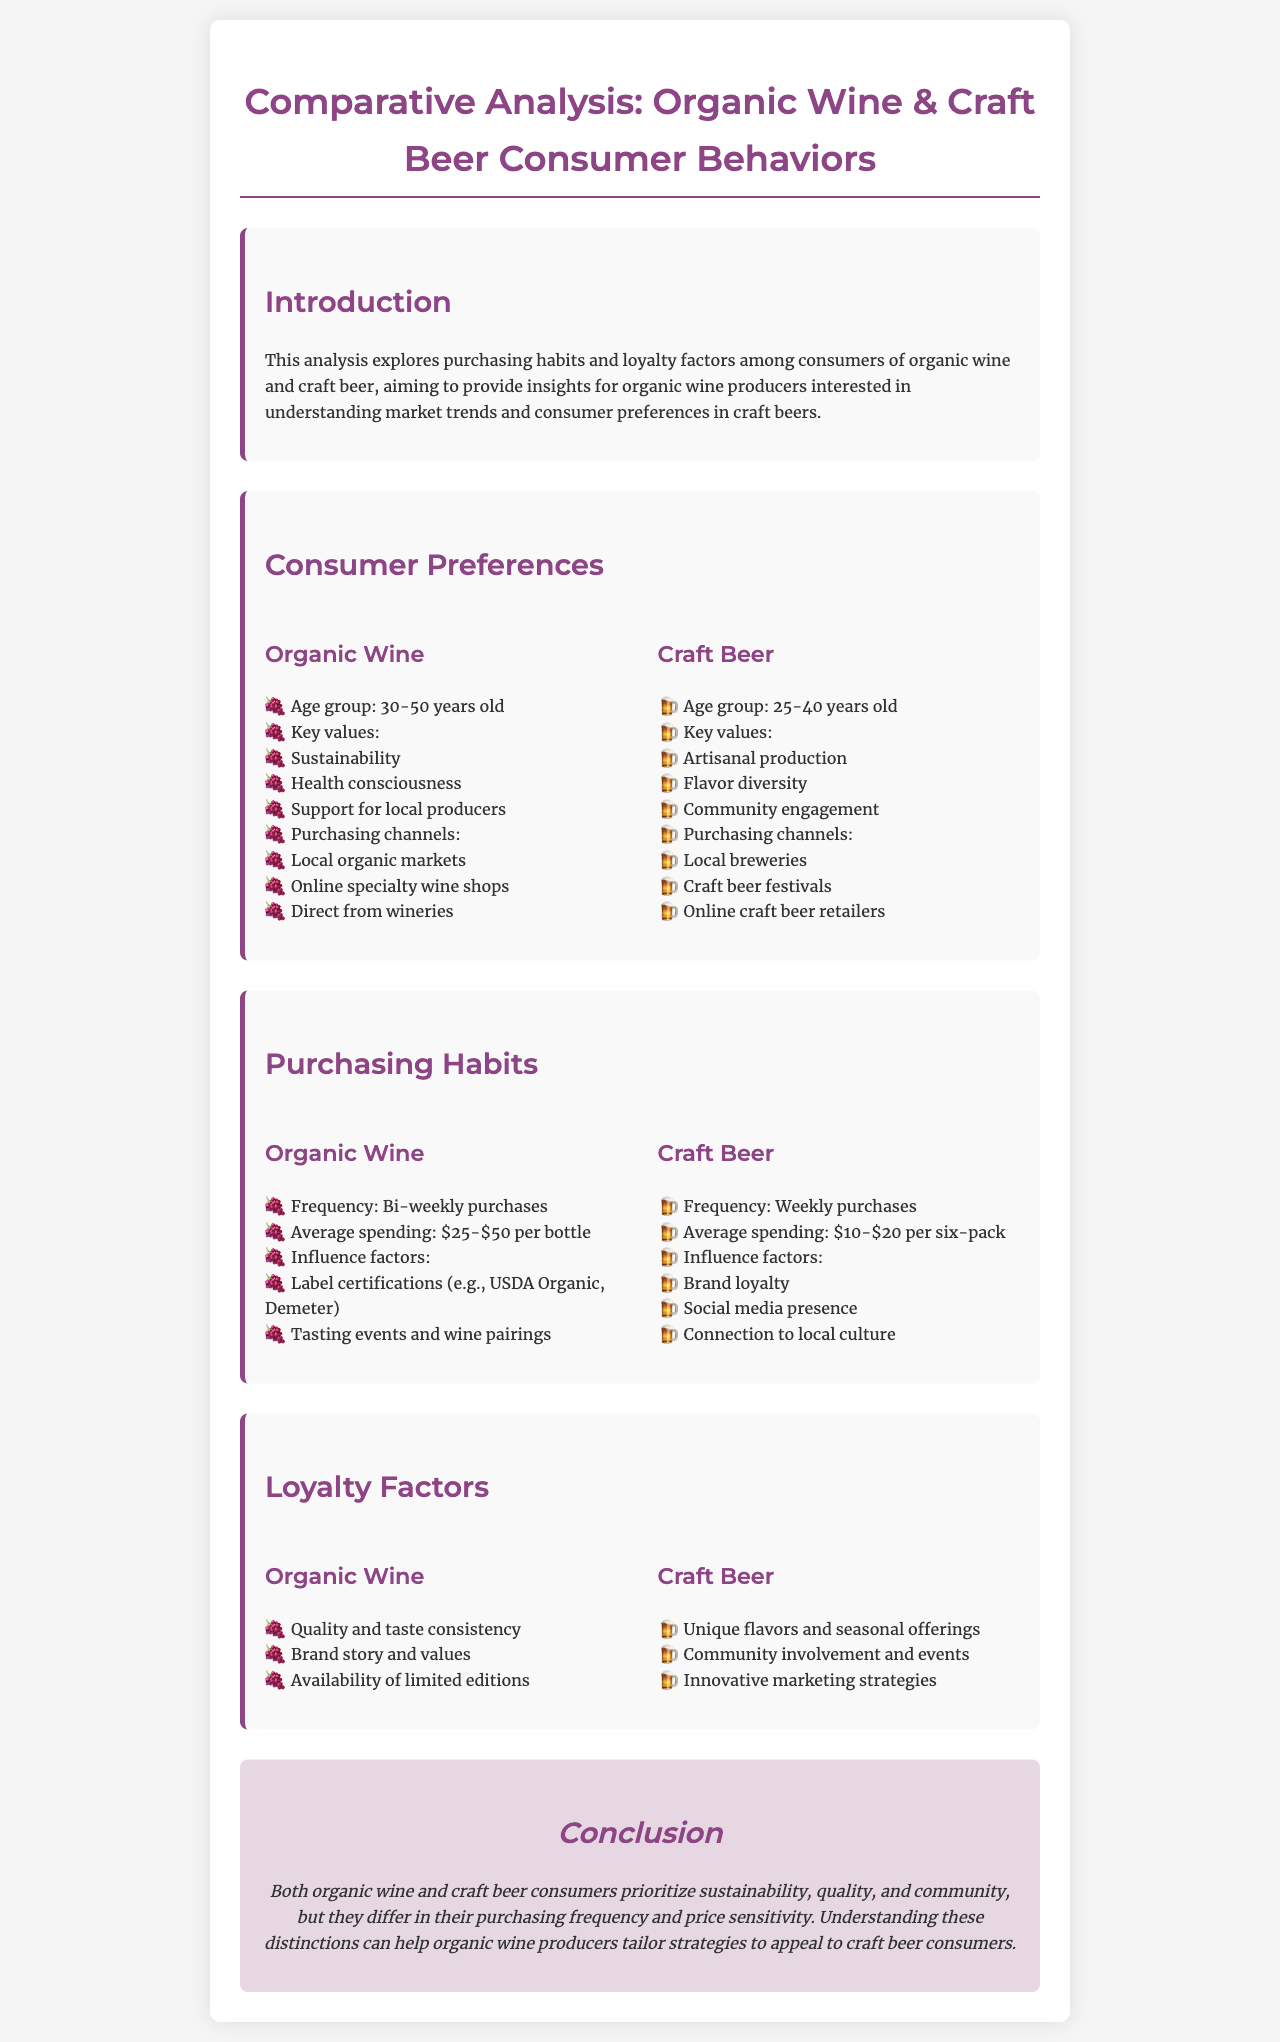What is the age group for organic wine consumers? The age group for organic wine consumers is specified as 30-50 years old in the document.
Answer: 30-50 years old What is the average spending on organic wine per bottle? The document states that the average spending on organic wine per bottle ranges from $25 to $50.
Answer: $25-$50 Which purchasing channel is least likely for craft beer consumers? The document lists purchasing channels for craft beer consumers; among these, "local organic markets" is not mentioned, implying it's least likely.
Answer: Local organic markets What is the frequency of purchasing craft beer? According to the document, the frequency of purchasing craft beer is specified as weekly.
Answer: Weekly What influences organic wine purchasing habits? The document indicates that label certifications and tasting events influence organic wine purchasing habits.
Answer: Label certifications and tasting events Which value is associated with craft beer consumers? The document mentions that 'artisanal production' is a key value for craft beer consumers.
Answer: Artisanal production What is a loyalty factor for organic wine? The document identifies 'quality and taste consistency' as a loyalty factor for organic wine consumers.
Answer: Quality and taste consistency What is a unique factor for craft beer consumers' loyalty? The document states that 'unique flavors and seasonal offerings' are a unique factor for craft beer consumers' loyalty.
Answer: Unique flavors and seasonal offerings What do both consumer groups prioritize? The document concludes that both organic wine and craft beer consumers prioritize sustainability.
Answer: Sustainability 